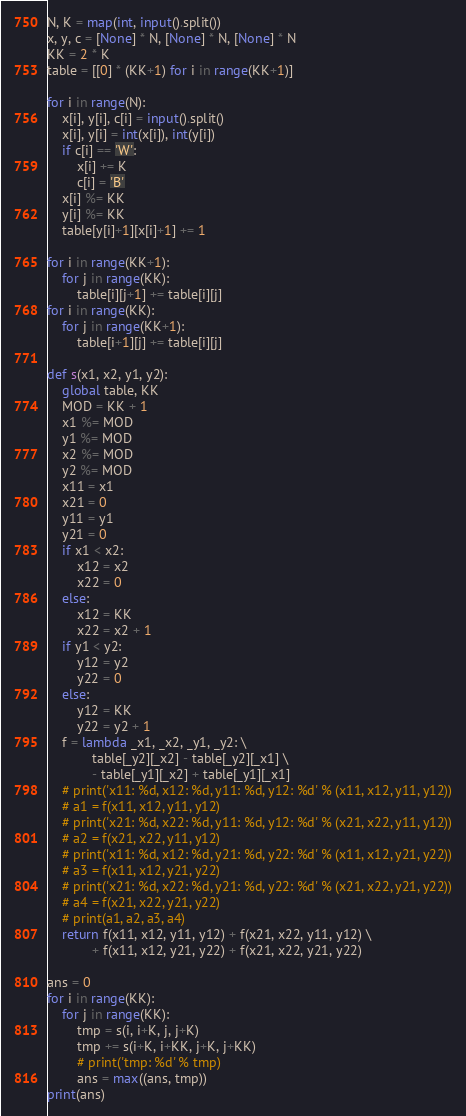<code> <loc_0><loc_0><loc_500><loc_500><_Python_>N, K = map(int, input().split())
x, y, c = [None] * N, [None] * N, [None] * N
KK = 2 * K
table = [[0] * (KK+1) for i in range(KK+1)]

for i in range(N):
    x[i], y[i], c[i] = input().split()
    x[i], y[i] = int(x[i]), int(y[i])
    if c[i] == 'W':
        x[i] += K
        c[i] = 'B'
    x[i] %= KK
    y[i] %= KK
    table[y[i]+1][x[i]+1] += 1

for i in range(KK+1):
    for j in range(KK):
        table[i][j+1] += table[i][j]
for i in range(KK):
    for j in range(KK+1):
        table[i+1][j] += table[i][j]

def s(x1, x2, y1, y2):
    global table, KK
    MOD = KK + 1
    x1 %= MOD
    y1 %= MOD
    x2 %= MOD
    y2 %= MOD
    x11 = x1
    x21 = 0
    y11 = y1
    y21 = 0
    if x1 < x2:
        x12 = x2
        x22 = 0
    else:
        x12 = KK
        x22 = x2 + 1
    if y1 < y2:
        y12 = y2
        y22 = 0
    else:
        y12 = KK
        y22 = y2 + 1
    f = lambda _x1, _x2, _y1, _y2: \
            table[_y2][_x2] - table[_y2][_x1] \
            - table[_y1][_x2] + table[_y1][_x1]
    # print('x11: %d, x12: %d, y11: %d, y12: %d' % (x11, x12, y11, y12))
    # a1 = f(x11, x12, y11, y12)
    # print('x21: %d, x22: %d, y11: %d, y12: %d' % (x21, x22, y11, y12))
    # a2 = f(x21, x22, y11, y12)
    # print('x11: %d, x12: %d, y21: %d, y22: %d' % (x11, x12, y21, y22))
    # a3 = f(x11, x12, y21, y22)
    # print('x21: %d, x22: %d, y21: %d, y22: %d' % (x21, x22, y21, y22))
    # a4 = f(x21, x22, y21, y22)
    # print(a1, a2, a3, a4)
    return f(x11, x12, y11, y12) + f(x21, x22, y11, y12) \
            + f(x11, x12, y21, y22) + f(x21, x22, y21, y22)

ans = 0
for i in range(KK):
    for j in range(KK):
        tmp = s(i, i+K, j, j+K)
        tmp += s(i+K, i+KK, j+K, j+KK)
        # print('tmp: %d' % tmp)
        ans = max((ans, tmp))
print(ans)
</code> 